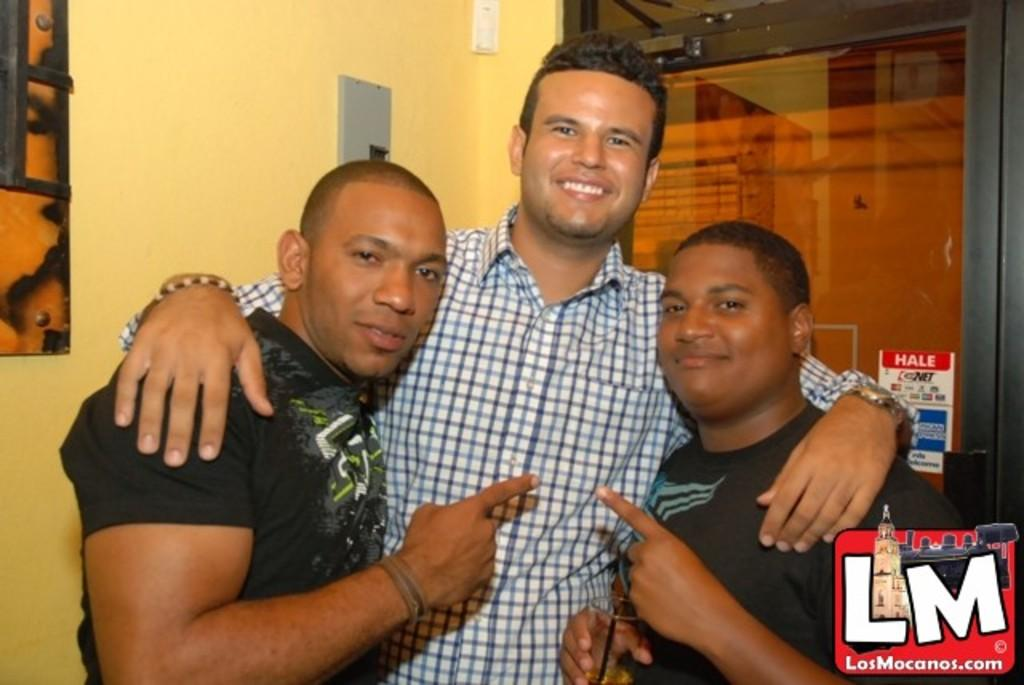How many people are present in the image? There are three people in the image. What can be seen in the background of the image? There is a wall, a door, and other objects in the background of the image. Can you describe the logo in the bottom right corner of the image? Unfortunately, the provided facts do not mention any details about the logo. What might the door in the background of the image be used for? The door in the background of the image might be used for entering or exiting a room or building. What type of cheese is being shared among the brothers in the image? There is no mention of cheese or brothers in the image. Can you tell me how many pigs are visible in the image? There are no pigs present in the image. 